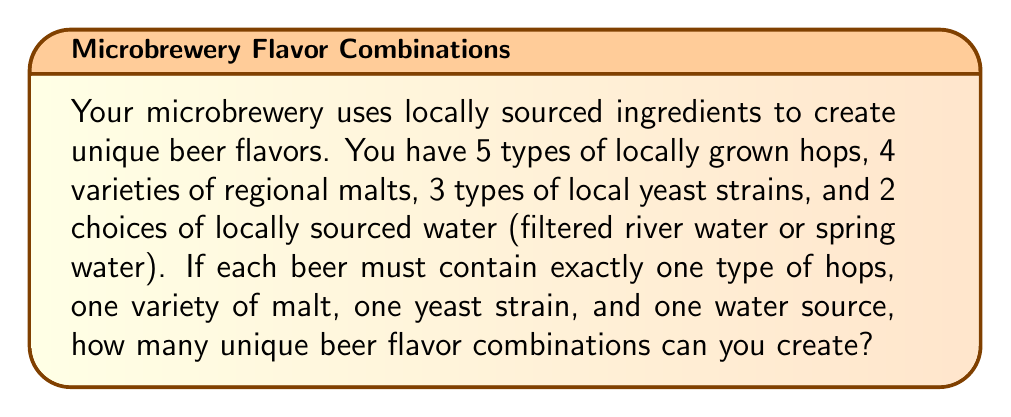Teach me how to tackle this problem. To solve this problem, we'll use the multiplication principle of counting. Since each beer must contain exactly one ingredient from each category, and the choice of one ingredient doesn't affect the choices for the others, we multiply the number of options for each category:

1. Number of hop choices: 5
2. Number of malt varieties: 4
3. Number of yeast strains: 3
4. Number of water sources: 2

The total number of unique combinations is:

$$ 5 \times 4 \times 3 \times 2 $$

Let's calculate this step by step:

$$ 5 \times 4 = 20 $$
$$ 20 \times 3 = 60 $$
$$ 60 \times 2 = 120 $$

Therefore, the microbrewery can create 120 unique beer flavor combinations using the locally sourced ingredients.
Answer: 120 combinations 